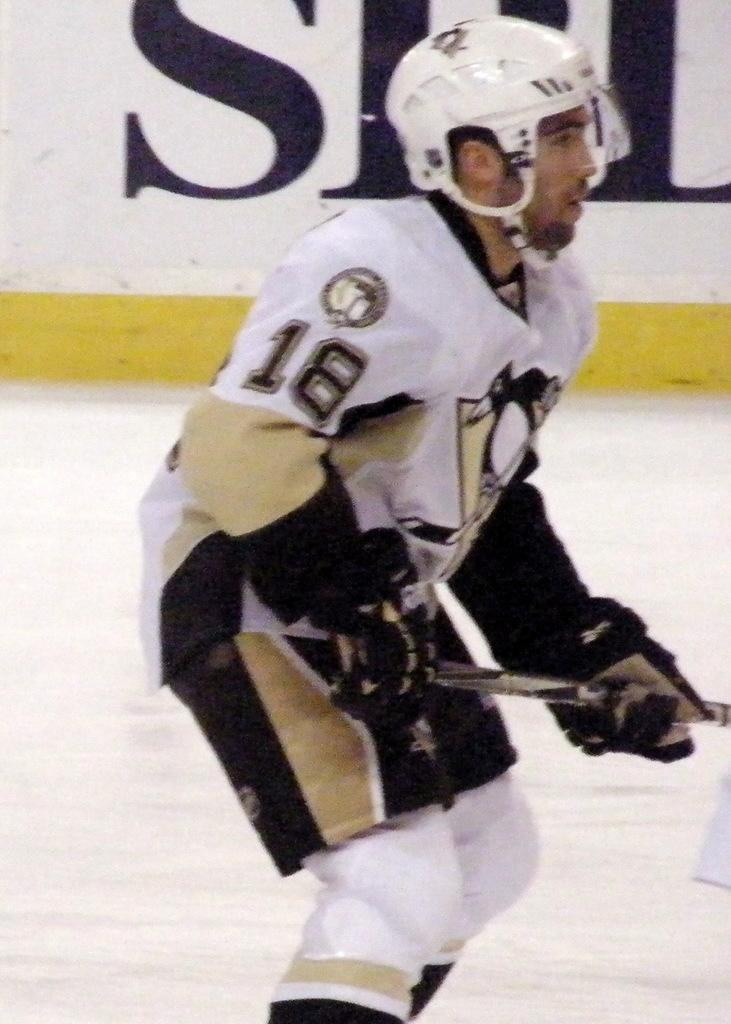What can be seen in the image? There is a person in the image. What is the person doing in the image? The person is holding an object. What type of surface is visible in the image? There is ground visible in the image. What other structure can be seen in the image? There is a wall in the image. What type of toy can be seen in the person's hand in the image? There is no toy visible in the person's hand in the image. 